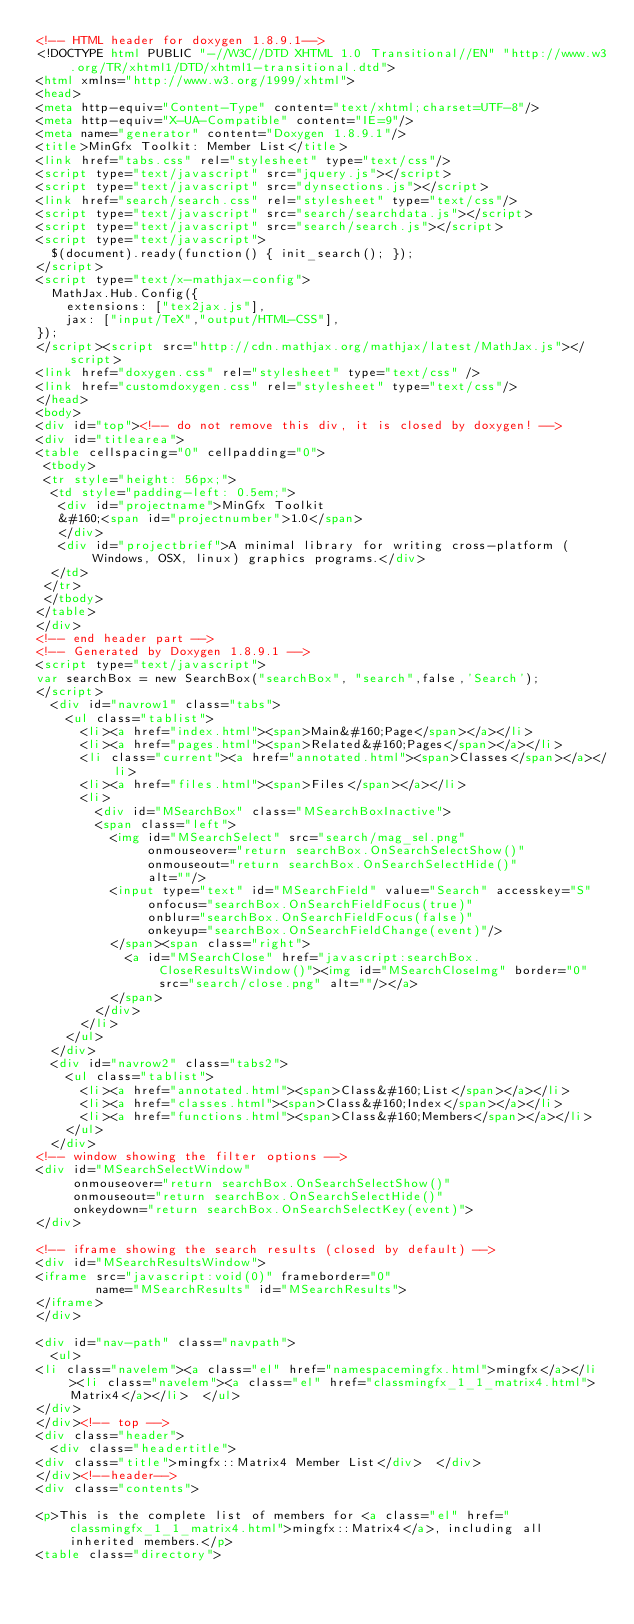<code> <loc_0><loc_0><loc_500><loc_500><_HTML_><!-- HTML header for doxygen 1.8.9.1-->
<!DOCTYPE html PUBLIC "-//W3C//DTD XHTML 1.0 Transitional//EN" "http://www.w3.org/TR/xhtml1/DTD/xhtml1-transitional.dtd">
<html xmlns="http://www.w3.org/1999/xhtml">
<head>
<meta http-equiv="Content-Type" content="text/xhtml;charset=UTF-8"/>
<meta http-equiv="X-UA-Compatible" content="IE=9"/>
<meta name="generator" content="Doxygen 1.8.9.1"/>
<title>MinGfx Toolkit: Member List</title>
<link href="tabs.css" rel="stylesheet" type="text/css"/>
<script type="text/javascript" src="jquery.js"></script>
<script type="text/javascript" src="dynsections.js"></script>
<link href="search/search.css" rel="stylesheet" type="text/css"/>
<script type="text/javascript" src="search/searchdata.js"></script>
<script type="text/javascript" src="search/search.js"></script>
<script type="text/javascript">
  $(document).ready(function() { init_search(); });
</script>
<script type="text/x-mathjax-config">
  MathJax.Hub.Config({
    extensions: ["tex2jax.js"],
    jax: ["input/TeX","output/HTML-CSS"],
});
</script><script src="http://cdn.mathjax.org/mathjax/latest/MathJax.js"></script>
<link href="doxygen.css" rel="stylesheet" type="text/css" />
<link href="customdoxygen.css" rel="stylesheet" type="text/css"/>
</head>
<body>
<div id="top"><!-- do not remove this div, it is closed by doxygen! -->
<div id="titlearea">
<table cellspacing="0" cellpadding="0">
 <tbody>
 <tr style="height: 56px;">
  <td style="padding-left: 0.5em;">
   <div id="projectname">MinGfx Toolkit
   &#160;<span id="projectnumber">1.0</span>
   </div>
   <div id="projectbrief">A minimal library for writing cross-platform (Windows, OSX, linux) graphics programs.</div>
  </td>
 </tr>
 </tbody>
</table>
</div>
<!-- end header part -->
<!-- Generated by Doxygen 1.8.9.1 -->
<script type="text/javascript">
var searchBox = new SearchBox("searchBox", "search",false,'Search');
</script>
  <div id="navrow1" class="tabs">
    <ul class="tablist">
      <li><a href="index.html"><span>Main&#160;Page</span></a></li>
      <li><a href="pages.html"><span>Related&#160;Pages</span></a></li>
      <li class="current"><a href="annotated.html"><span>Classes</span></a></li>
      <li><a href="files.html"><span>Files</span></a></li>
      <li>
        <div id="MSearchBox" class="MSearchBoxInactive">
        <span class="left">
          <img id="MSearchSelect" src="search/mag_sel.png"
               onmouseover="return searchBox.OnSearchSelectShow()"
               onmouseout="return searchBox.OnSearchSelectHide()"
               alt=""/>
          <input type="text" id="MSearchField" value="Search" accesskey="S"
               onfocus="searchBox.OnSearchFieldFocus(true)" 
               onblur="searchBox.OnSearchFieldFocus(false)" 
               onkeyup="searchBox.OnSearchFieldChange(event)"/>
          </span><span class="right">
            <a id="MSearchClose" href="javascript:searchBox.CloseResultsWindow()"><img id="MSearchCloseImg" border="0" src="search/close.png" alt=""/></a>
          </span>
        </div>
      </li>
    </ul>
  </div>
  <div id="navrow2" class="tabs2">
    <ul class="tablist">
      <li><a href="annotated.html"><span>Class&#160;List</span></a></li>
      <li><a href="classes.html"><span>Class&#160;Index</span></a></li>
      <li><a href="functions.html"><span>Class&#160;Members</span></a></li>
    </ul>
  </div>
<!-- window showing the filter options -->
<div id="MSearchSelectWindow"
     onmouseover="return searchBox.OnSearchSelectShow()"
     onmouseout="return searchBox.OnSearchSelectHide()"
     onkeydown="return searchBox.OnSearchSelectKey(event)">
</div>

<!-- iframe showing the search results (closed by default) -->
<div id="MSearchResultsWindow">
<iframe src="javascript:void(0)" frameborder="0" 
        name="MSearchResults" id="MSearchResults">
</iframe>
</div>

<div id="nav-path" class="navpath">
  <ul>
<li class="navelem"><a class="el" href="namespacemingfx.html">mingfx</a></li><li class="navelem"><a class="el" href="classmingfx_1_1_matrix4.html">Matrix4</a></li>  </ul>
</div>
</div><!-- top -->
<div class="header">
  <div class="headertitle">
<div class="title">mingfx::Matrix4 Member List</div>  </div>
</div><!--header-->
<div class="contents">

<p>This is the complete list of members for <a class="el" href="classmingfx_1_1_matrix4.html">mingfx::Matrix4</a>, including all inherited members.</p>
<table class="directory"></code> 